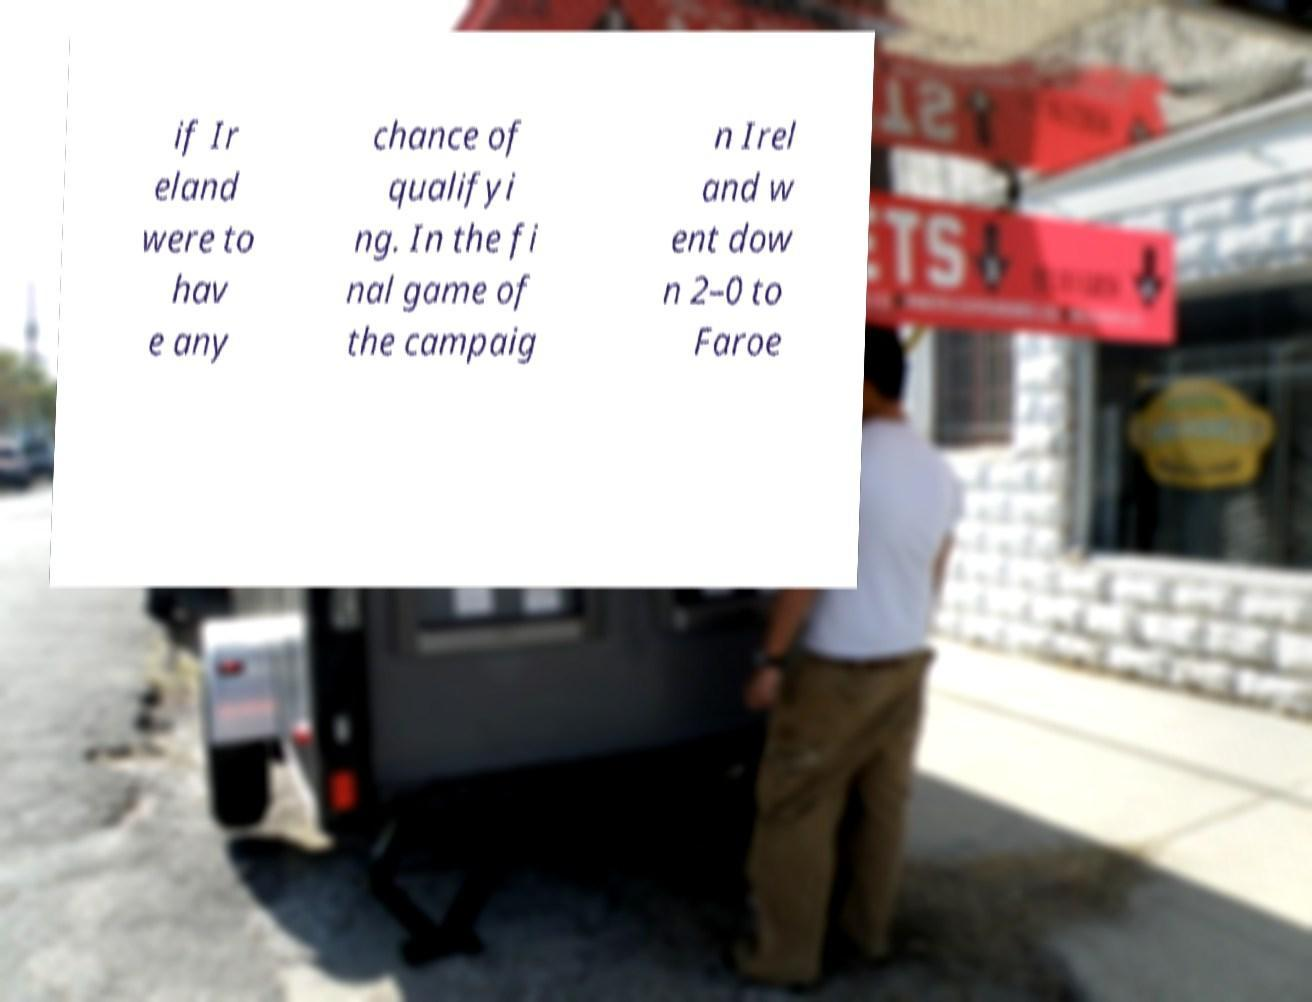Please read and relay the text visible in this image. What does it say? if Ir eland were to hav e any chance of qualifyi ng. In the fi nal game of the campaig n Irel and w ent dow n 2–0 to Faroe 